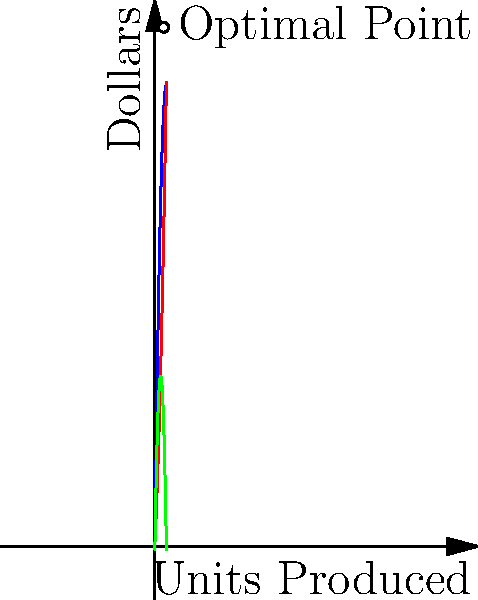As a busy entrepreneur, you're analyzing a new product line. The revenue function (in thousands of dollars) is given by $R(x) = -0.1x^2 + 80x$, and the cost function is $C(x) = 0.05x^2 + 20x + 100$, where $x$ is the number of units produced. Using calculus, determine the production level that maximizes profit and calculate the maximum profit. 1. Define the profit function:
   $P(x) = R(x) - C(x) = (-0.1x^2 + 80x) - (0.05x^2 + 20x + 100)$
   $P(x) = -0.15x^2 + 60x - 100$

2. To find the maximum profit, we need to find where $\frac{dP}{dx} = 0$:
   $\frac{dP}{dx} = -0.3x + 60$

3. Set $\frac{dP}{dx} = 0$ and solve for x:
   $-0.3x + 60 = 0$
   $-0.3x = -60$
   $x = 200$

4. Verify it's a maximum by checking the second derivative:
   $\frac{d^2P}{dx^2} = -0.3 < 0$, confirming a maximum.

5. Calculate the maximum profit by plugging $x = 200$ into $P(x)$:
   $P(200) = -0.15(200)^2 + 60(200) - 100$
   $= -6000 + 12000 - 100$
   $= 5900$

The maximum profit is $5,900,000 when producing 200 units.
Answer: 200 units; $5,900,000 